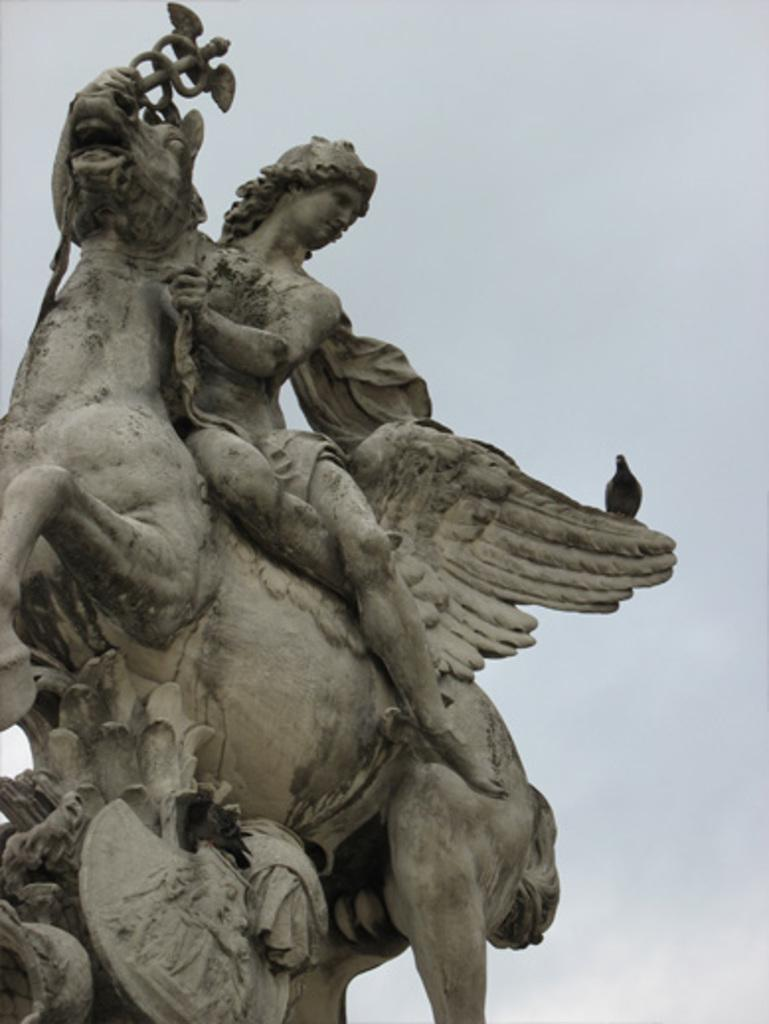What is the main subject of the image? The main subject of the image is a statue with birds on it. Can you describe the birds on the statue? The birds are perched on the statue. What can be seen in the background of the image? The sky is visible in the background of the image. What type of machine is being played by the birds in the image? There is no machine present in the image, and the birds are not playing any instruments. 